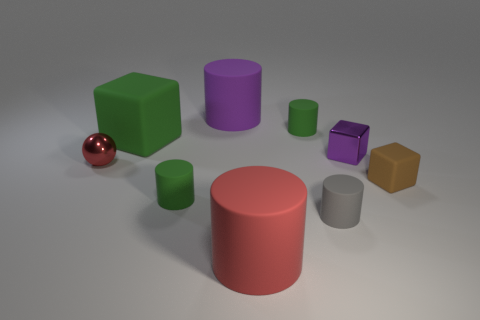What number of large red rubber cylinders are in front of the red cylinder?
Provide a short and direct response. 0. Are there any spheres right of the small thing that is left of the matte cube that is left of the small gray cylinder?
Your answer should be very brief. No. What number of rubber blocks are the same size as the brown matte object?
Offer a very short reply. 0. What is the material of the large thing in front of the tiny gray matte cylinder that is behind the red matte object?
Give a very brief answer. Rubber. What shape is the thing right of the purple thing right of the tiny green rubber object that is on the right side of the big red cylinder?
Your answer should be very brief. Cube. Is the shape of the brown thing to the right of the purple cylinder the same as the small metal object that is to the left of the small gray thing?
Ensure brevity in your answer.  No. How many other things are made of the same material as the tiny gray thing?
Offer a terse response. 6. What is the shape of the tiny brown thing that is the same material as the gray object?
Offer a very short reply. Cube. Do the purple rubber thing and the green block have the same size?
Your answer should be very brief. Yes. What is the size of the red thing that is on the left side of the rubber cube that is to the left of the large red rubber cylinder?
Offer a very short reply. Small. 